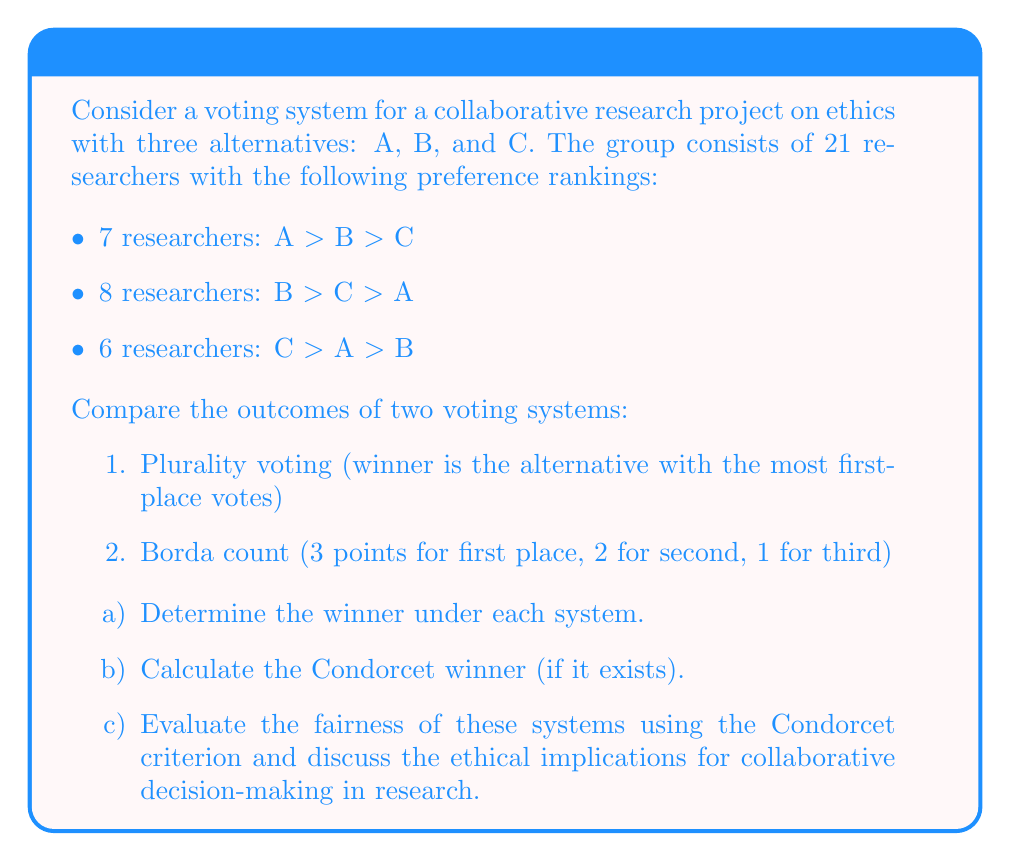Can you answer this question? Let's approach this problem step-by-step:

a) Determining the winners:

1. Plurality voting:
   A: 7 votes
   B: 8 votes
   C: 6 votes

   Winner: B with 8 votes

2. Borda count:
   A: (7 × 3) + (0 × 2) + (6 × 1) = 27 points
   B: (8 × 3) + (7 × 2) + (0 × 1) = 38 points
   C: (6 × 3) + (8 × 2) + (7 × 1) = 35 points

   Winner: B with 38 points

b) Calculating the Condorcet winner:

To find the Condorcet winner, we need to compare each alternative against every other in pairwise comparisons:

A vs B: 
   A preferred by 13 (7 + 6)
   B preferred by 8
   A wins

A vs C:
   A preferred by 7
   C preferred by 14 (8 + 6)
   C wins

B vs C:
   B preferred by 15 (7 + 8)
   C preferred by 6
   B wins

There is no Condorcet winner, as no alternative wins all pairwise comparisons.

c) Evaluation of fairness:

The Condorcet criterion states that if there exists a Condorcet winner (an alternative that wins all pairwise comparisons), it should be the overall winner of the election.

In this case, there is no Condorcet winner. However, we can still evaluate the fairness of the two systems:

1. Plurality voting: 
   - Chooses B, which wins one pairwise comparison (against C)
   - Fails to account for the strength of preferences beyond first choice

2. Borda count:
   - Also chooses B, which wins one pairwise comparison (against C)
   - Takes into account the full ranking of preferences
   - More closely aligns with the pairwise comparison results

Ethical implications:

1. Representation: The Borda count provides a more nuanced representation of group preferences, which is important for collaborative research where diverse perspectives are valued.

2. Compromise: The Borda count encourages compromise by considering second and third choices, which may lead to more cohesive group decisions in ethical research.

3. Minority voices: Plurality voting may silence minority opinions, which could be crucial in ethical discussions. The Borda count gives some weight to these perspectives.

4. Strategic voting: The Borda count is less susceptible to strategic voting than plurality voting, promoting more honest preference expression.

5. Consensus-building: Neither system guarantees a Condorcet winner, which might necessitate further discussion and refinement of alternatives in ethical decision-making processes.

In conclusion, while neither system is perfect, the Borda count appears to be fairer and more suitable for collaborative ethical research, as it better captures the nuances of group preferences and encourages compromise.
Answer: a) Winner under plurality voting: B
   Winner under Borda count: B

b) No Condorcet winner exists

c) The Borda count is fairer and more suitable for collaborative ethical research, as it better represents group preferences, encourages compromise, and considers minority opinions. However, both systems have limitations in fully satisfying the Condorcet criterion, suggesting that additional discussion and consensus-building may be necessary for ethical decision-making in research collaborations. 